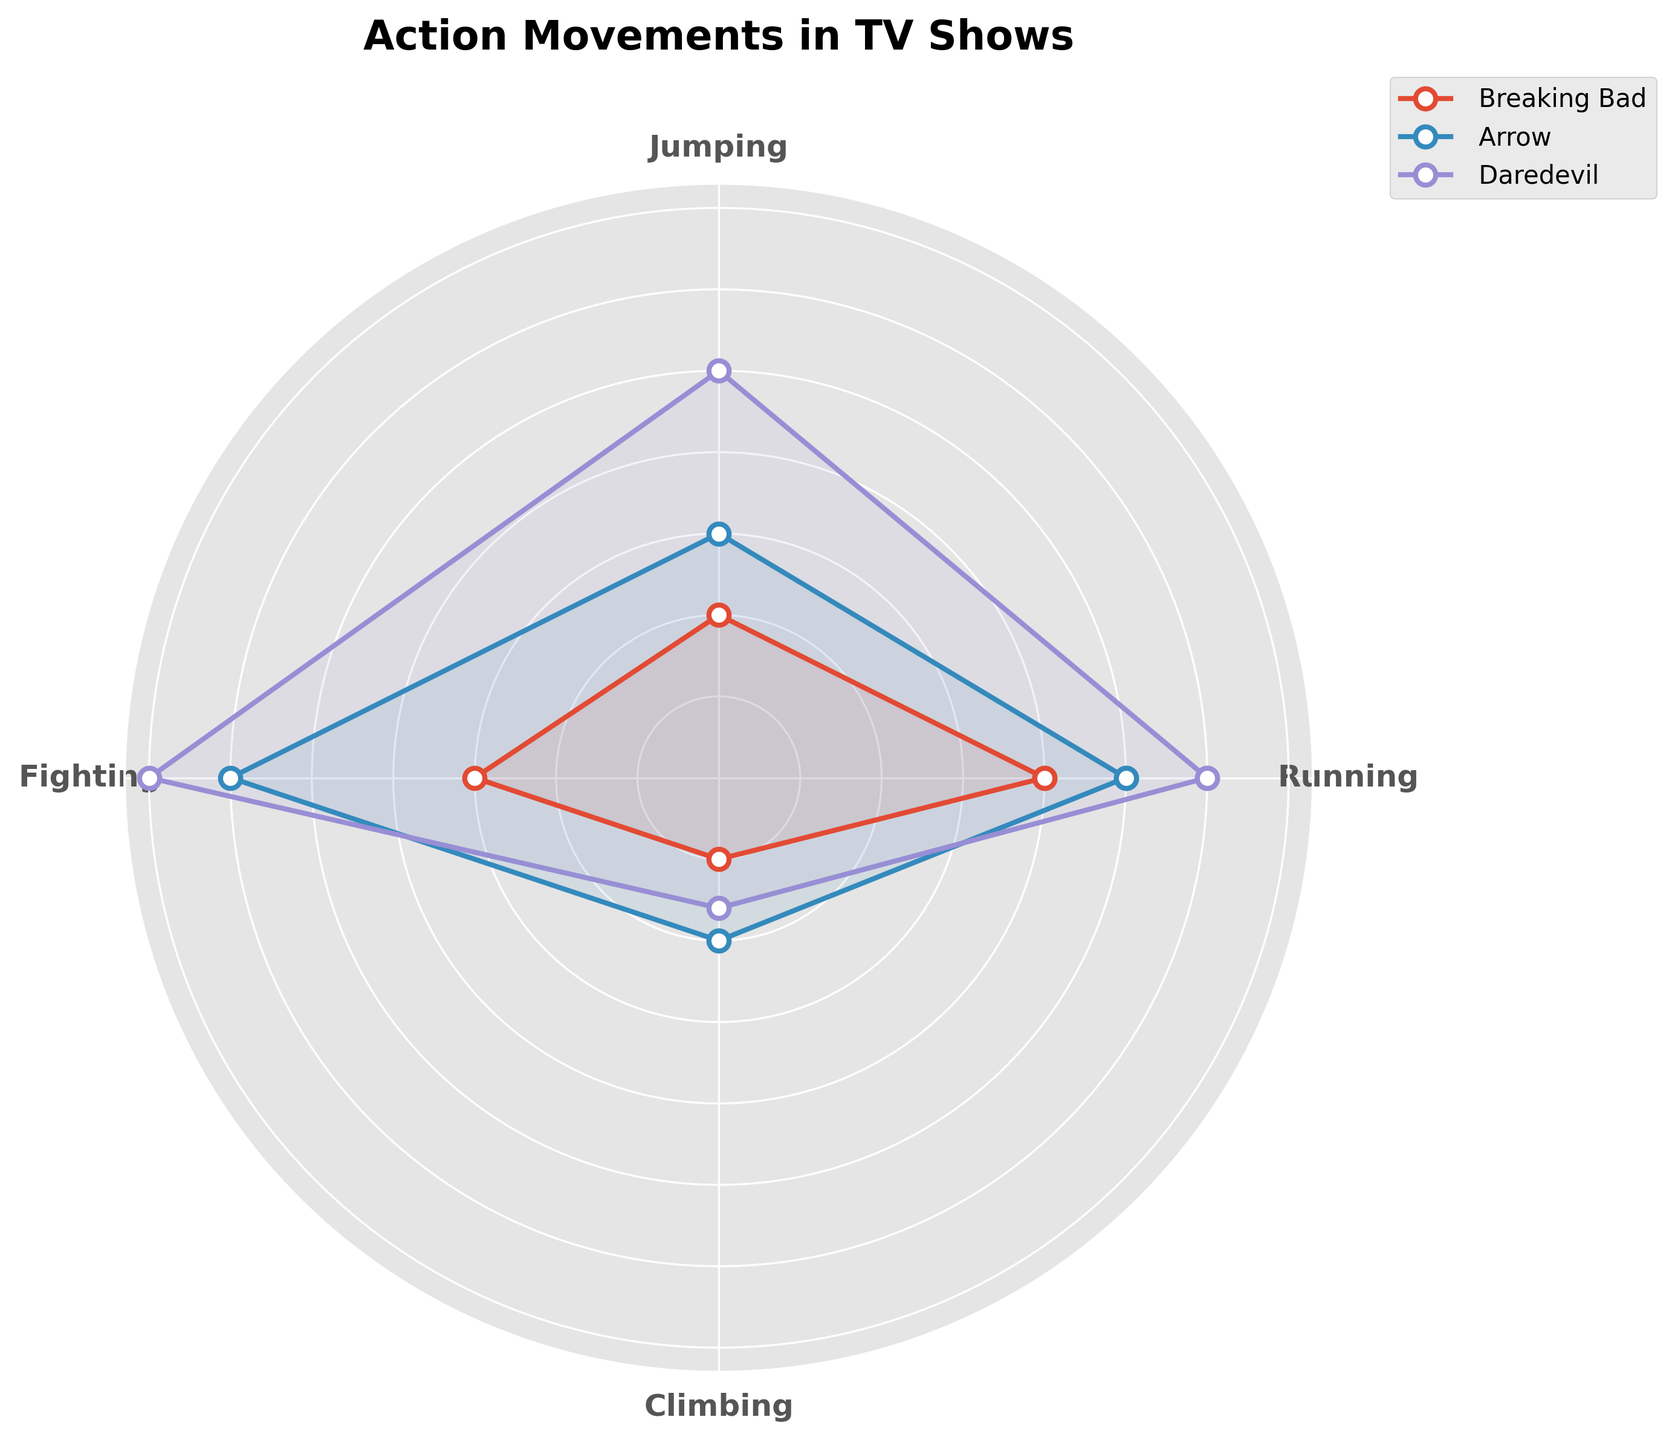Which TV show features the highest frequency of running movements? To determine this, look at the values for running in the radar chart and identify the highest point among the shows.
Answer: Daredevil What is the total frequency of fighting movements across all TV shows? Add the frequencies of fighting for Breaking Bad (15), Arrow (30), and Daredevil (35). Sum them up: 15 + 30 + 35.
Answer: 80 Which movement is generally the least frequent across all TV shows? Observe each movement type's values on the radar chart and find the smallest overall values by comparing visually.
Answer: Climbing Which TV show has the most balanced or evenly distributed types of movements? In a balanced radar chart, the values form a circle around the center. Look for the show where the plot is more circular and even.
Answer: Breaking Bad What is the difference in jumping movements between Arrow and Daredevil? Subtract the jumping value of Arrow (15) from Daredevil's jumping value (25): 25 - 15.
Answer: 10 Which type of movement is most frequent in Arrow? Identify the highest point on Arrow’s line in the radar chart to see which type it corresponds to.
Answer: Fighting If you sum up all types of movements for Breaking Bad, what is the total frequency? Add the frequencies for all movements in Breaking Bad: Running (20), Jumping (10), Fighting (15), Climbing (5). Calculation: 20 + 10 + 15 + 5.
Answer: 50 Which TV show exhibits the greatest variety in movement frequencies? The radar chart with the most spread-out points indicates the most variance. Check which show has the largest differences between its highest and lowest values.
Answer: Daredevil Between Breaking Bad and Arrow, which has more climbing movements? Compare the climbing values of both TV shows, Breaking Bad (5) and Arrow (10).
Answer: Arrow 